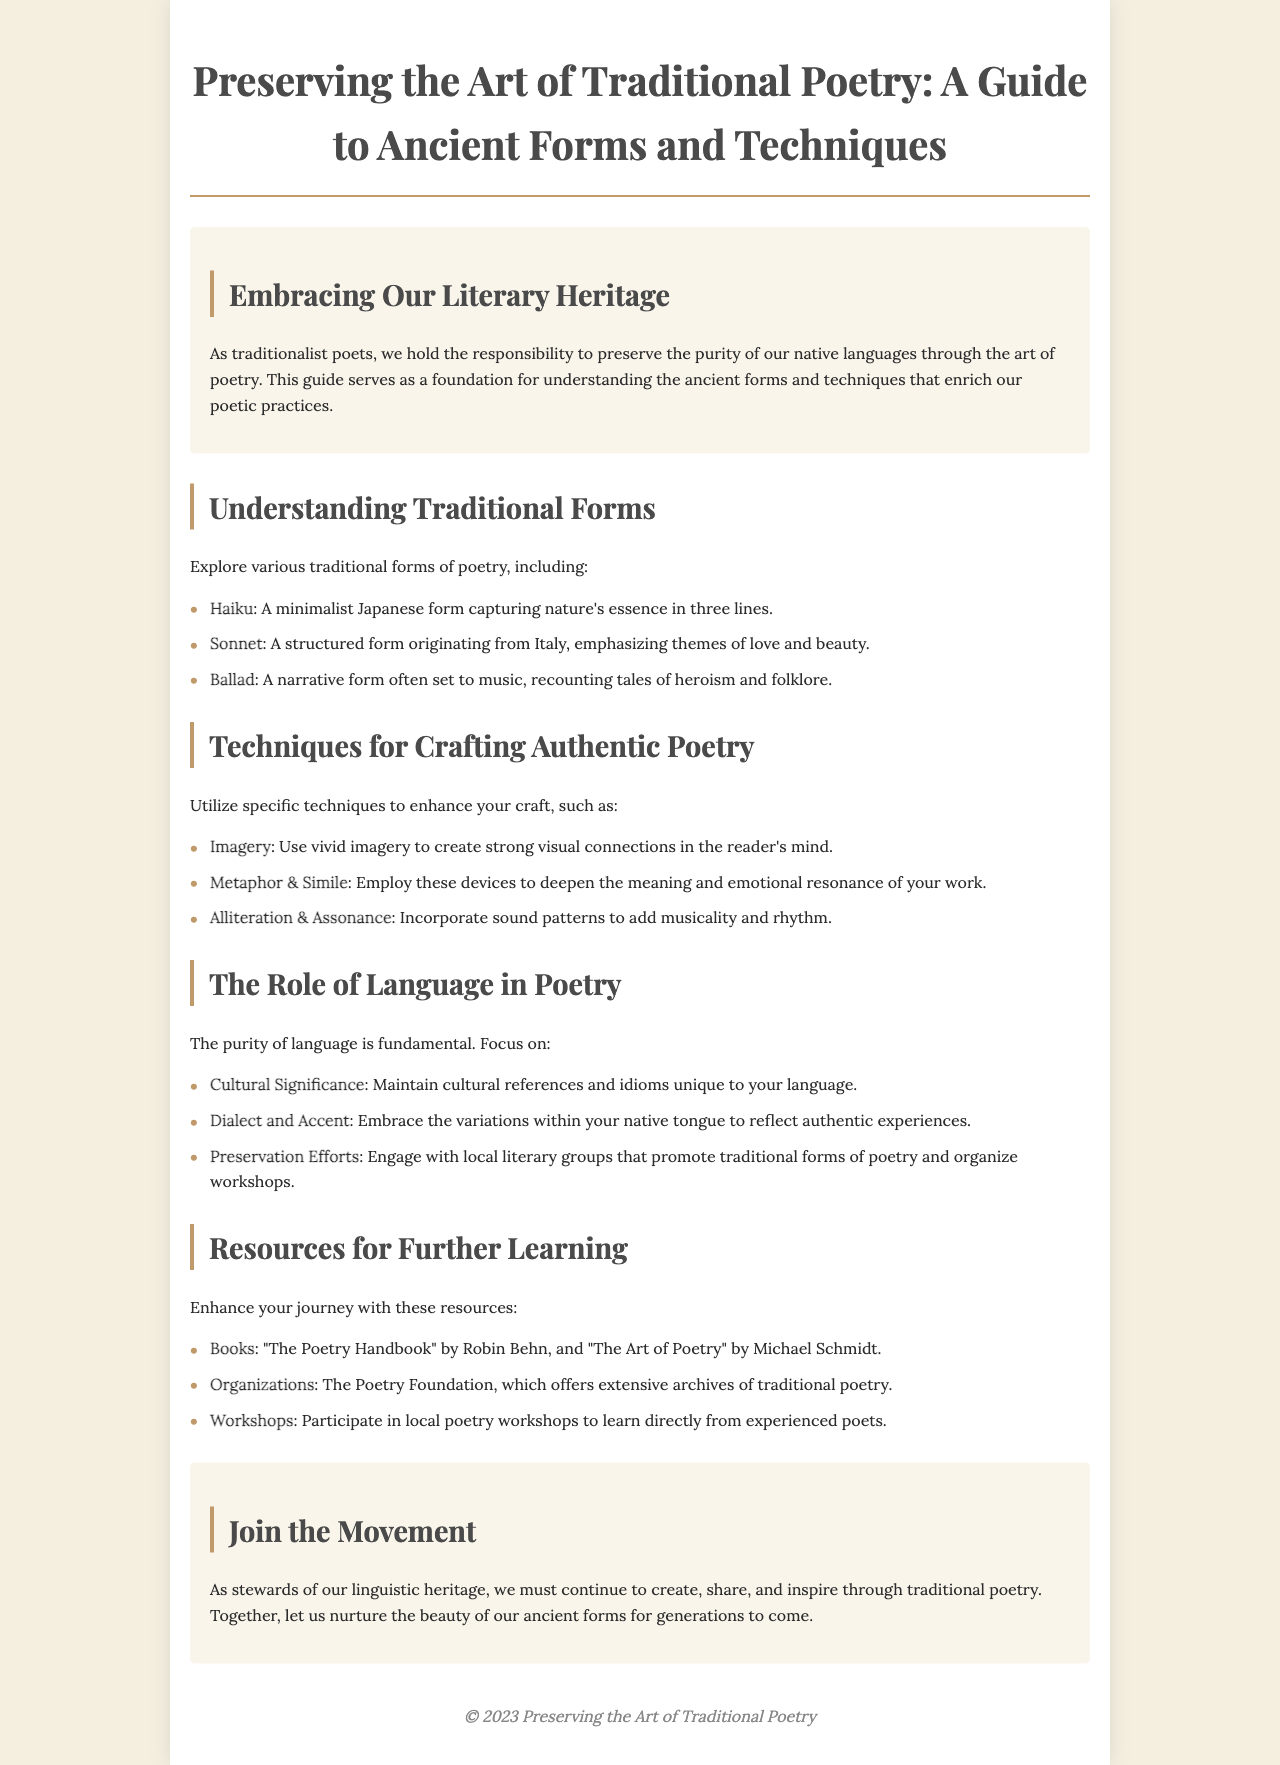what is the title of the brochure? The title is displayed prominently at the top of the document, summarizing the brochure's focus.
Answer: Preserving the Art of Traditional Poetry: A Guide to Ancient Forms and Techniques what are the three traditional forms of poetry mentioned? These forms are listed under the 'Understanding Traditional Forms' section as examples of poetic practices.
Answer: Haiku, Sonnet, Ballad what technique is emphasized for enhancing poetic craft? This is highlighted in the section titled 'Techniques for Crafting Authentic Poetry'.
Answer: Imagery which organization is mentioned as a resource? The name of the organization is stated in the 'Resources for Further Learning' section as a recommended place for additional information on poetry.
Answer: The Poetry Foundation what is one aspect of language that poets should focus on? This is outlined in the section discussing the importance of language in poetry.
Answer: Cultural Significance how many sections are there in the brochure? The brochure consists of several structured sections, including an introduction and conclusion.
Answer: Five what year is noted in the footer? The footer typically contains copyright information including a year signifying the document's publication.
Answer: 2023 what is the purpose of this brochure? The main goal of the brochure is stated in the introduction, highlighting its intent to guide poets.
Answer: Preservation of traditional poetry 